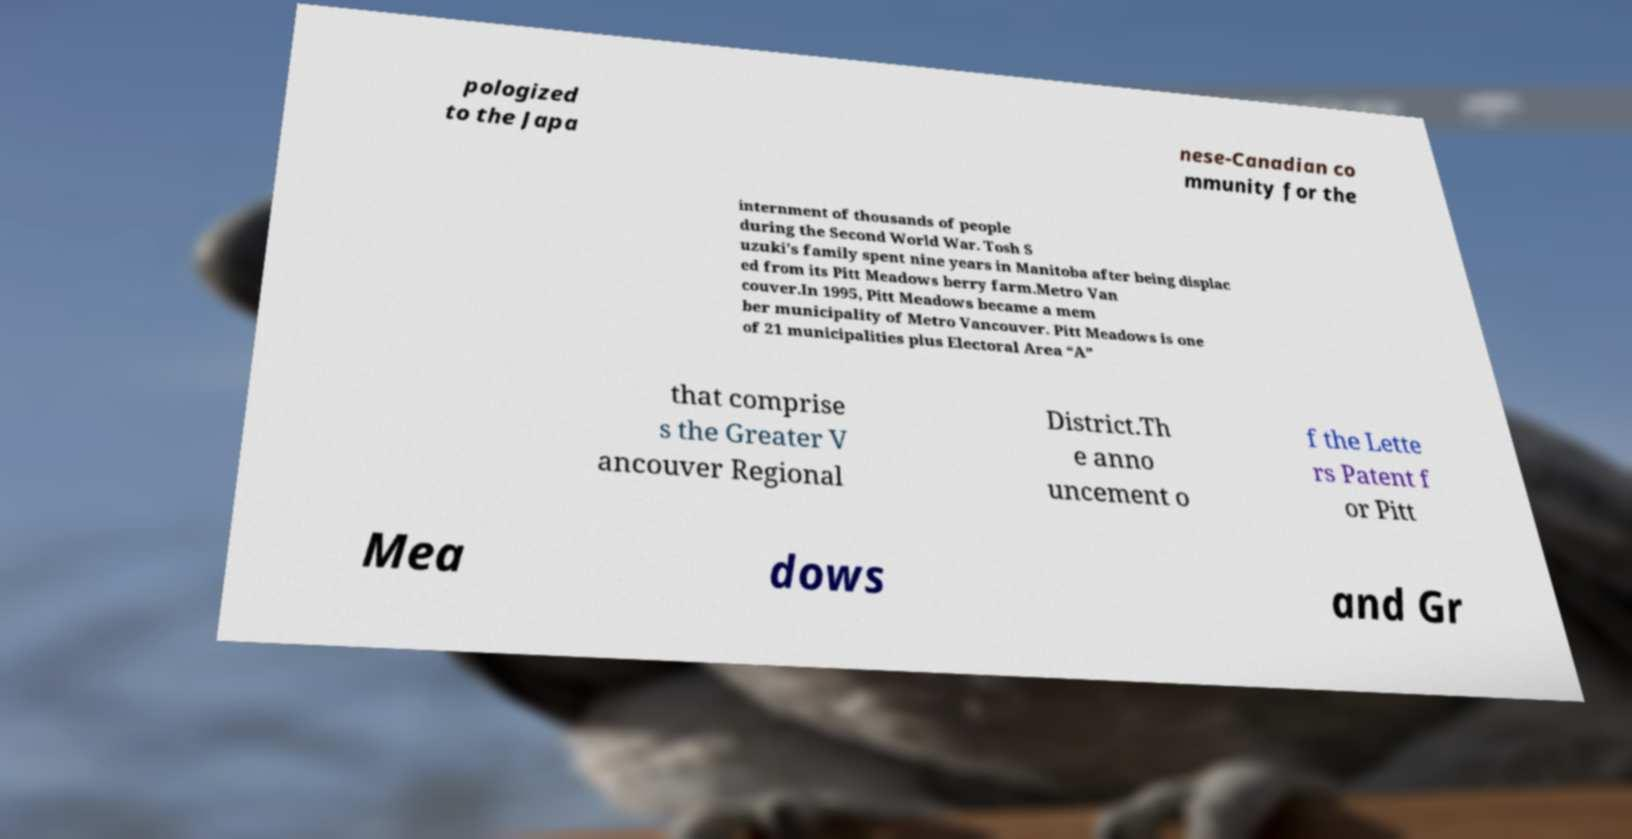Please read and relay the text visible in this image. What does it say? pologized to the Japa nese-Canadian co mmunity for the internment of thousands of people during the Second World War. Tosh S uzuki's family spent nine years in Manitoba after being displac ed from its Pitt Meadows berry farm.Metro Van couver.In 1995, Pitt Meadows became a mem ber municipality of Metro Vancouver. Pitt Meadows is one of 21 municipalities plus Electoral Area “A” that comprise s the Greater V ancouver Regional District.Th e anno uncement o f the Lette rs Patent f or Pitt Mea dows and Gr 